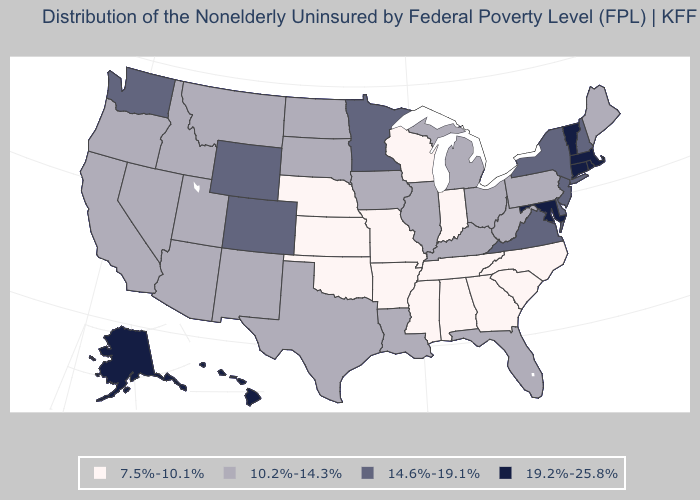Does Connecticut have the lowest value in the USA?
Answer briefly. No. Which states have the lowest value in the USA?
Keep it brief. Alabama, Arkansas, Georgia, Indiana, Kansas, Mississippi, Missouri, Nebraska, North Carolina, Oklahoma, South Carolina, Tennessee, Wisconsin. What is the lowest value in states that border Montana?
Answer briefly. 10.2%-14.3%. What is the value of Indiana?
Be succinct. 7.5%-10.1%. What is the value of Hawaii?
Be succinct. 19.2%-25.8%. What is the value of Florida?
Write a very short answer. 10.2%-14.3%. What is the value of Arkansas?
Answer briefly. 7.5%-10.1%. What is the value of North Carolina?
Give a very brief answer. 7.5%-10.1%. How many symbols are there in the legend?
Concise answer only. 4. Does Virginia have the lowest value in the USA?
Write a very short answer. No. What is the highest value in the USA?
Concise answer only. 19.2%-25.8%. Does Massachusetts have the highest value in the USA?
Answer briefly. Yes. Does the first symbol in the legend represent the smallest category?
Quick response, please. Yes. Which states have the highest value in the USA?
Give a very brief answer. Alaska, Connecticut, Hawaii, Maryland, Massachusetts, Rhode Island, Vermont. Does California have a lower value than Nevada?
Give a very brief answer. No. 